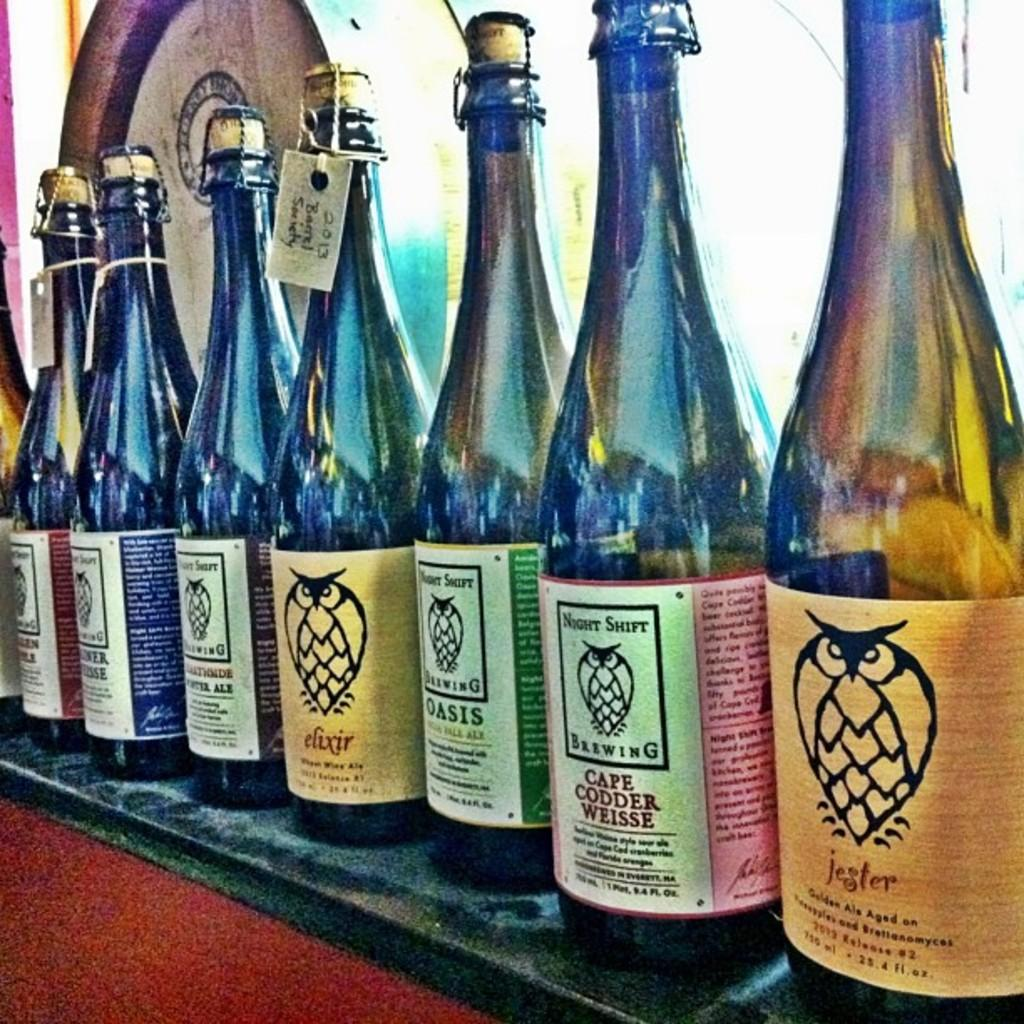<image>
Present a compact description of the photo's key features. the word jester is written on a bottle 